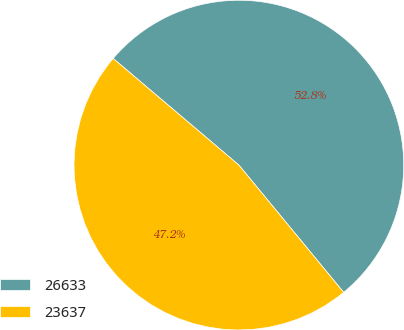Convert chart to OTSL. <chart><loc_0><loc_0><loc_500><loc_500><pie_chart><fcel>26633<fcel>23637<nl><fcel>52.84%<fcel>47.16%<nl></chart> 